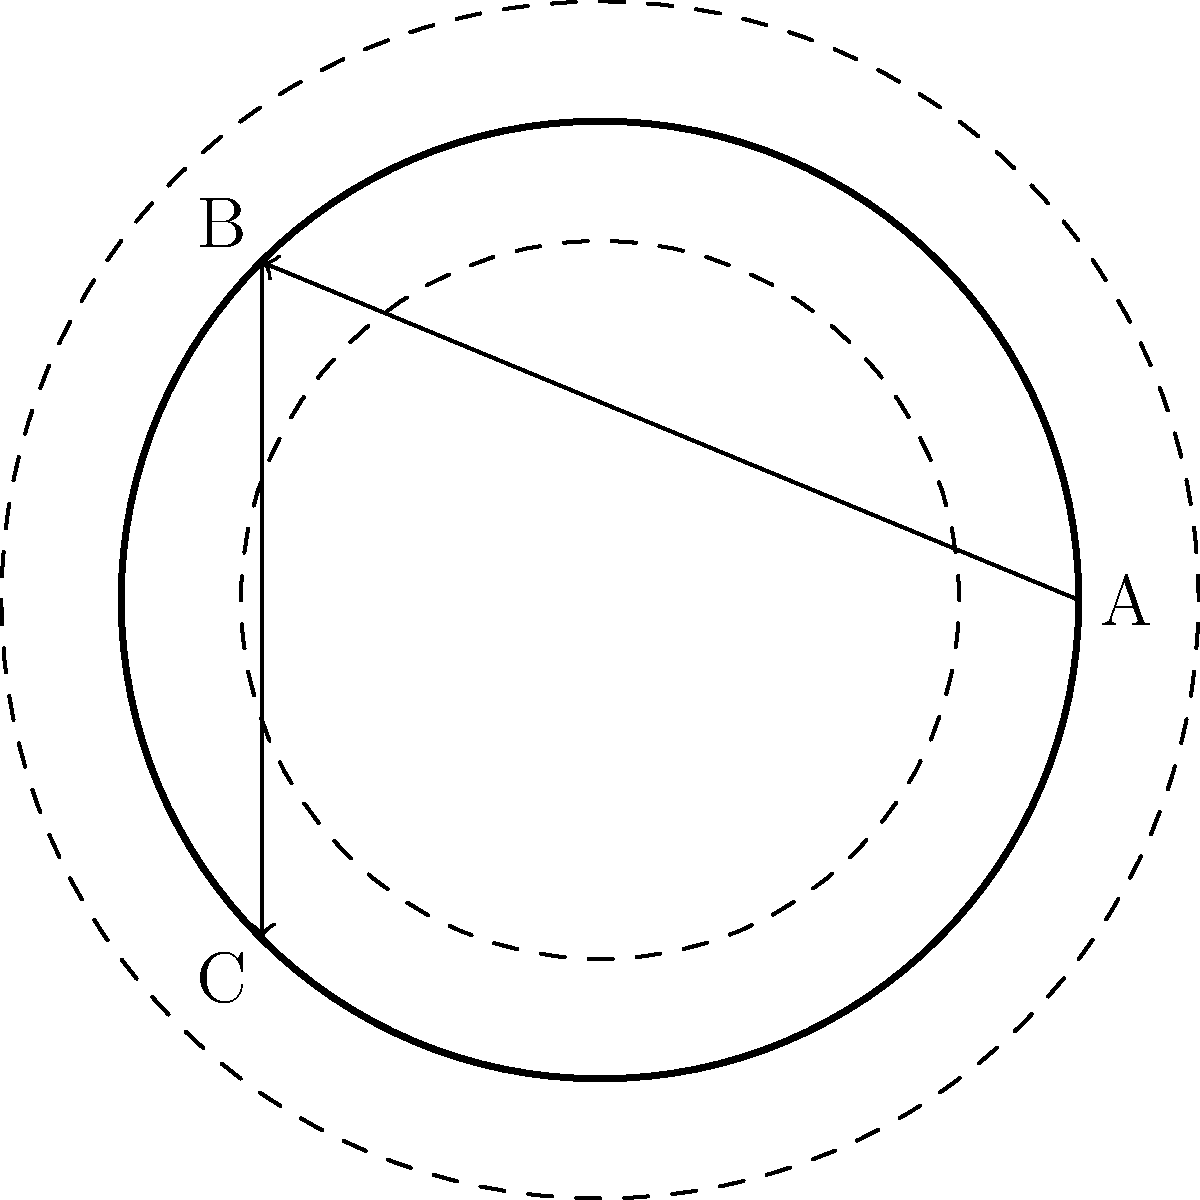On a unique torus-shaped motorcycle racing circuit, you need to calculate the shortest distance from point A to point C, passing through point B. The torus has a major radius of 2 units and a minor radius of 0.5 units. If the straight-line distance from A to B is $\frac{\pi}{2}$ units, and the straight-line distance from B to C is $\pi$ units, what is the total shortest distance from A to C on the surface of the torus? To solve this problem, we need to understand that the shortest path between two points on a torus is not always a straight line. Let's break it down step by step:

1) The torus surface can be represented as a rectangle with periodic boundary conditions. The width of this rectangle is the circumference of the major circle (4π units), and the height is the circumference of the minor circle (π units).

2) The given distances (A to B: $\frac{\pi}{2}$, and B to C: $\pi$) are measured along the surface of the torus, not through its interior.

3) On the flattened torus (rectangle), these distances correspond to:
   - A to B: $\frac{\pi}{2}$ units horizontally
   - B to C: $\pi$ units vertically

4) The total distance from A to C is the sum of these two distances:

   $$\text{Total Distance} = \frac{\pi}{2} + \pi = \frac{3\pi}{2}$$

5) We need to check if there's a shorter path. On a torus, we can "wrap around" the surface. However, in this case, any other path would be longer:
   - Going the other way horizontally would be $\frac{7\pi}{2}$ units
   - Any diagonal path would be longer than the orthogonal path given

6) Therefore, the shortest path from A to C, passing through B, is indeed $\frac{3\pi}{2}$ units.
Answer: $\frac{3\pi}{2}$ units 